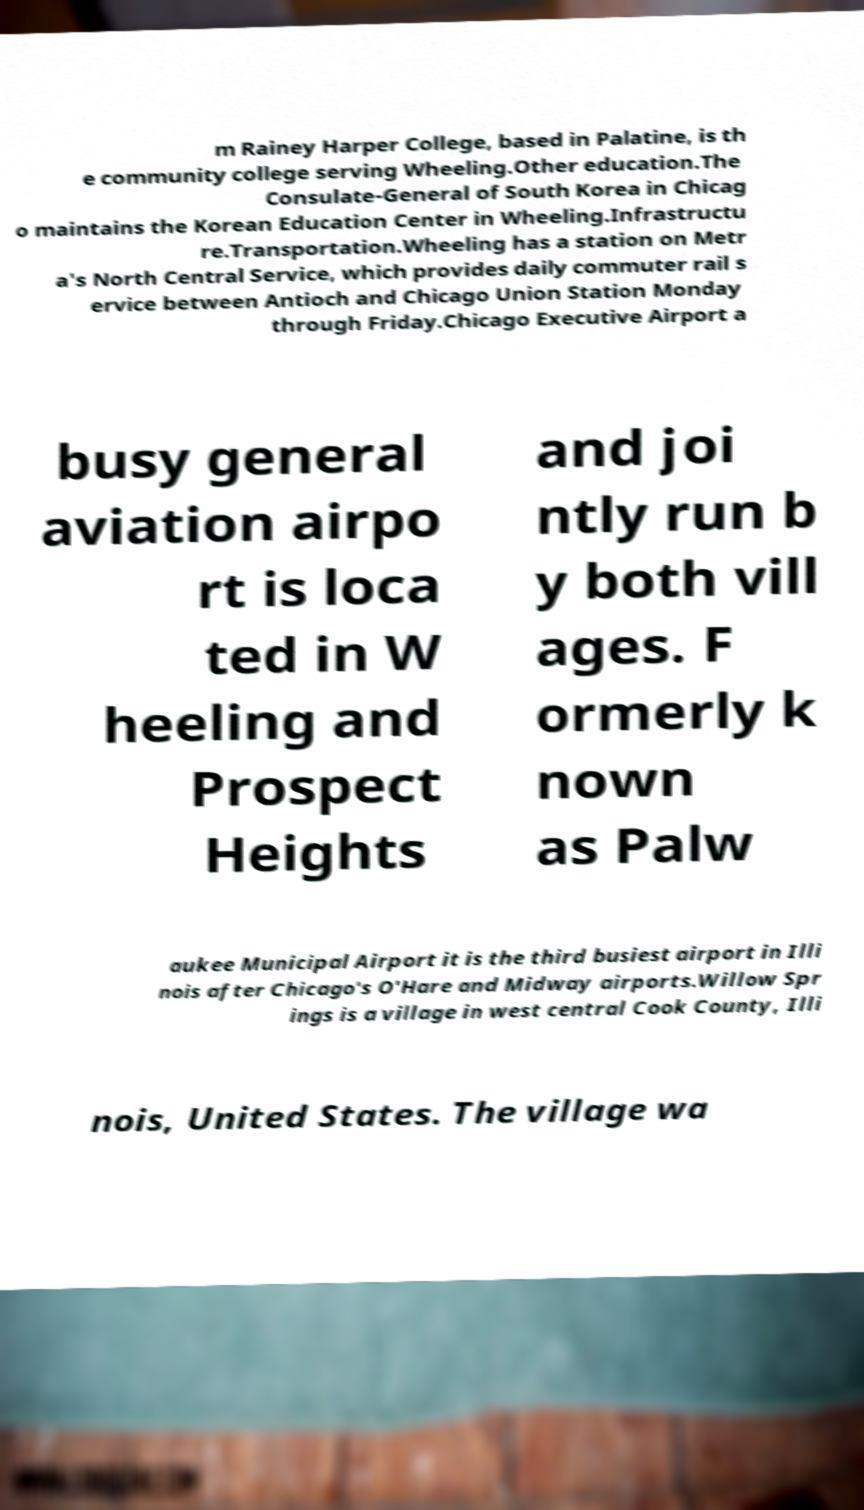For documentation purposes, I need the text within this image transcribed. Could you provide that? m Rainey Harper College, based in Palatine, is th e community college serving Wheeling.Other education.The Consulate-General of South Korea in Chicag o maintains the Korean Education Center in Wheeling.Infrastructu re.Transportation.Wheeling has a station on Metr a's North Central Service, which provides daily commuter rail s ervice between Antioch and Chicago Union Station Monday through Friday.Chicago Executive Airport a busy general aviation airpo rt is loca ted in W heeling and Prospect Heights and joi ntly run b y both vill ages. F ormerly k nown as Palw aukee Municipal Airport it is the third busiest airport in Illi nois after Chicago's O'Hare and Midway airports.Willow Spr ings is a village in west central Cook County, Illi nois, United States. The village wa 